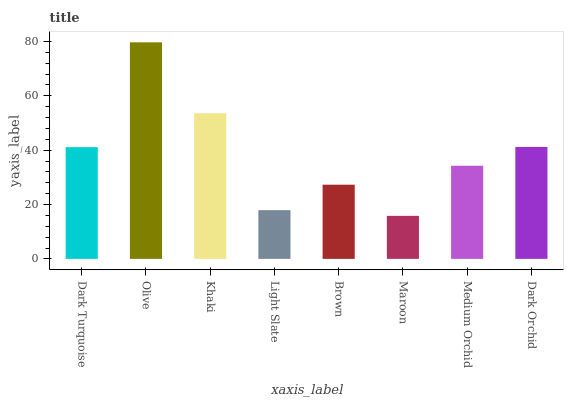Is Khaki the minimum?
Answer yes or no. No. Is Khaki the maximum?
Answer yes or no. No. Is Olive greater than Khaki?
Answer yes or no. Yes. Is Khaki less than Olive?
Answer yes or no. Yes. Is Khaki greater than Olive?
Answer yes or no. No. Is Olive less than Khaki?
Answer yes or no. No. Is Dark Turquoise the high median?
Answer yes or no. Yes. Is Medium Orchid the low median?
Answer yes or no. Yes. Is Light Slate the high median?
Answer yes or no. No. Is Olive the low median?
Answer yes or no. No. 